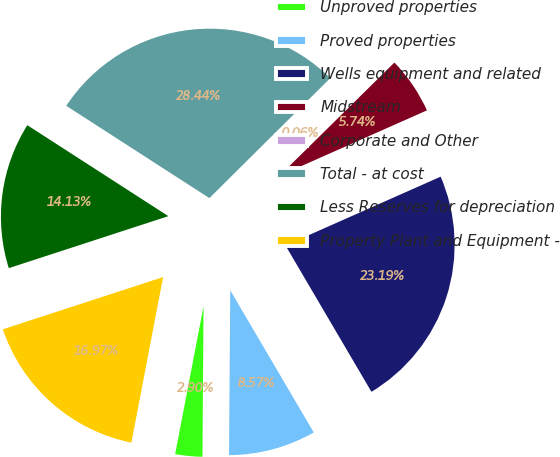Convert chart. <chart><loc_0><loc_0><loc_500><loc_500><pie_chart><fcel>Unproved properties<fcel>Proved properties<fcel>Wells equipment and related<fcel>Midstream<fcel>Corporate and Other<fcel>Total - at cost<fcel>Less Reserves for depreciation<fcel>Property Plant and Equipment -<nl><fcel>2.9%<fcel>8.57%<fcel>23.19%<fcel>5.74%<fcel>0.06%<fcel>28.44%<fcel>14.13%<fcel>16.97%<nl></chart> 